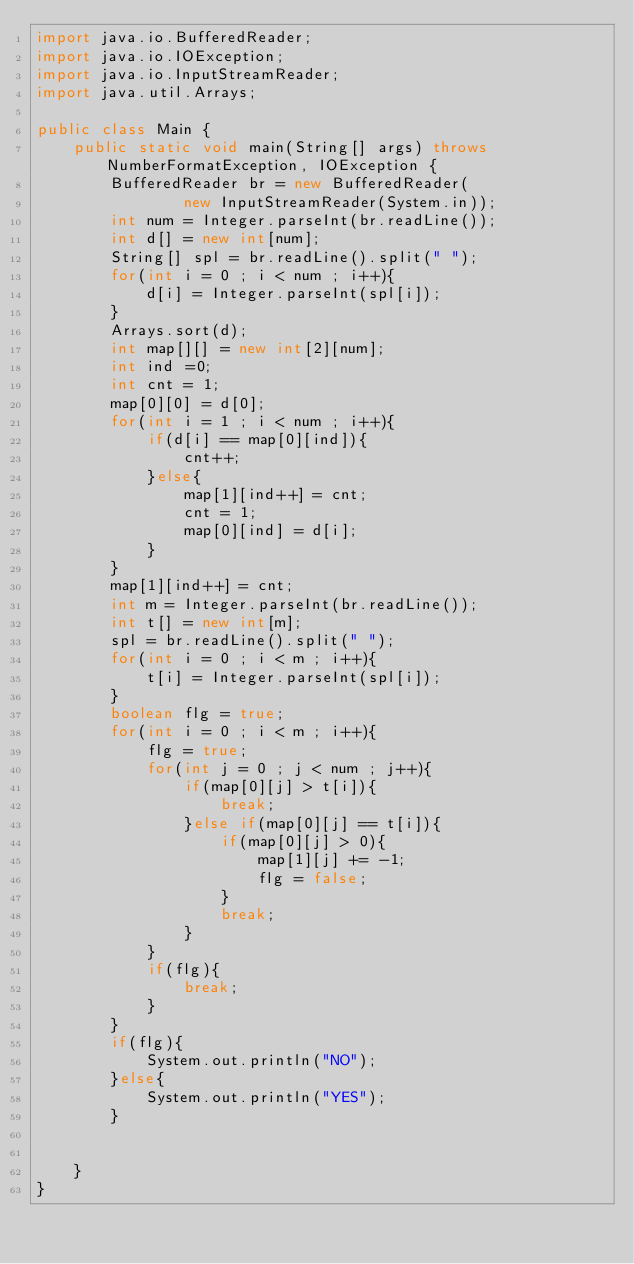Convert code to text. <code><loc_0><loc_0><loc_500><loc_500><_Java_>import java.io.BufferedReader;
import java.io.IOException;
import java.io.InputStreamReader;
import java.util.Arrays;
 
public class Main {
	public static void main(String[] args) throws NumberFormatException, IOException {
		BufferedReader br = new BufferedReader(
				new InputStreamReader(System.in));
		int num = Integer.parseInt(br.readLine());
		int d[] = new int[num];
		String[] spl = br.readLine().split(" ");
		for(int i = 0 ; i < num ; i++){
			d[i] = Integer.parseInt(spl[i]);
		}
		Arrays.sort(d);
		int map[][] = new int[2][num];
		int ind =0;
		int cnt = 1;
		map[0][0] = d[0];
		for(int i = 1 ; i < num ; i++){
			if(d[i] == map[0][ind]){
				cnt++;
			}else{
				map[1][ind++] = cnt;
				cnt = 1;
				map[0][ind] = d[i];
			}
		}
		map[1][ind++] = cnt;
		int m = Integer.parseInt(br.readLine());
		int t[] = new int[m];
		spl = br.readLine().split(" ");
		for(int i = 0 ; i < m ; i++){
			t[i] = Integer.parseInt(spl[i]);
		}
		boolean flg = true;
		for(int i = 0 ; i < m ; i++){
			flg = true;
			for(int j = 0 ; j < num ; j++){
				if(map[0][j] > t[i]){
					break;
				}else if(map[0][j] == t[i]){
					if(map[0][j] > 0){
						map[1][j] += -1;
						flg = false;
					}
					break;
				}
			}
			if(flg){
				break;
			}
		}
		if(flg){
			System.out.println("NO");
		}else{
			System.out.println("YES");
		}
		
		
	}
}</code> 